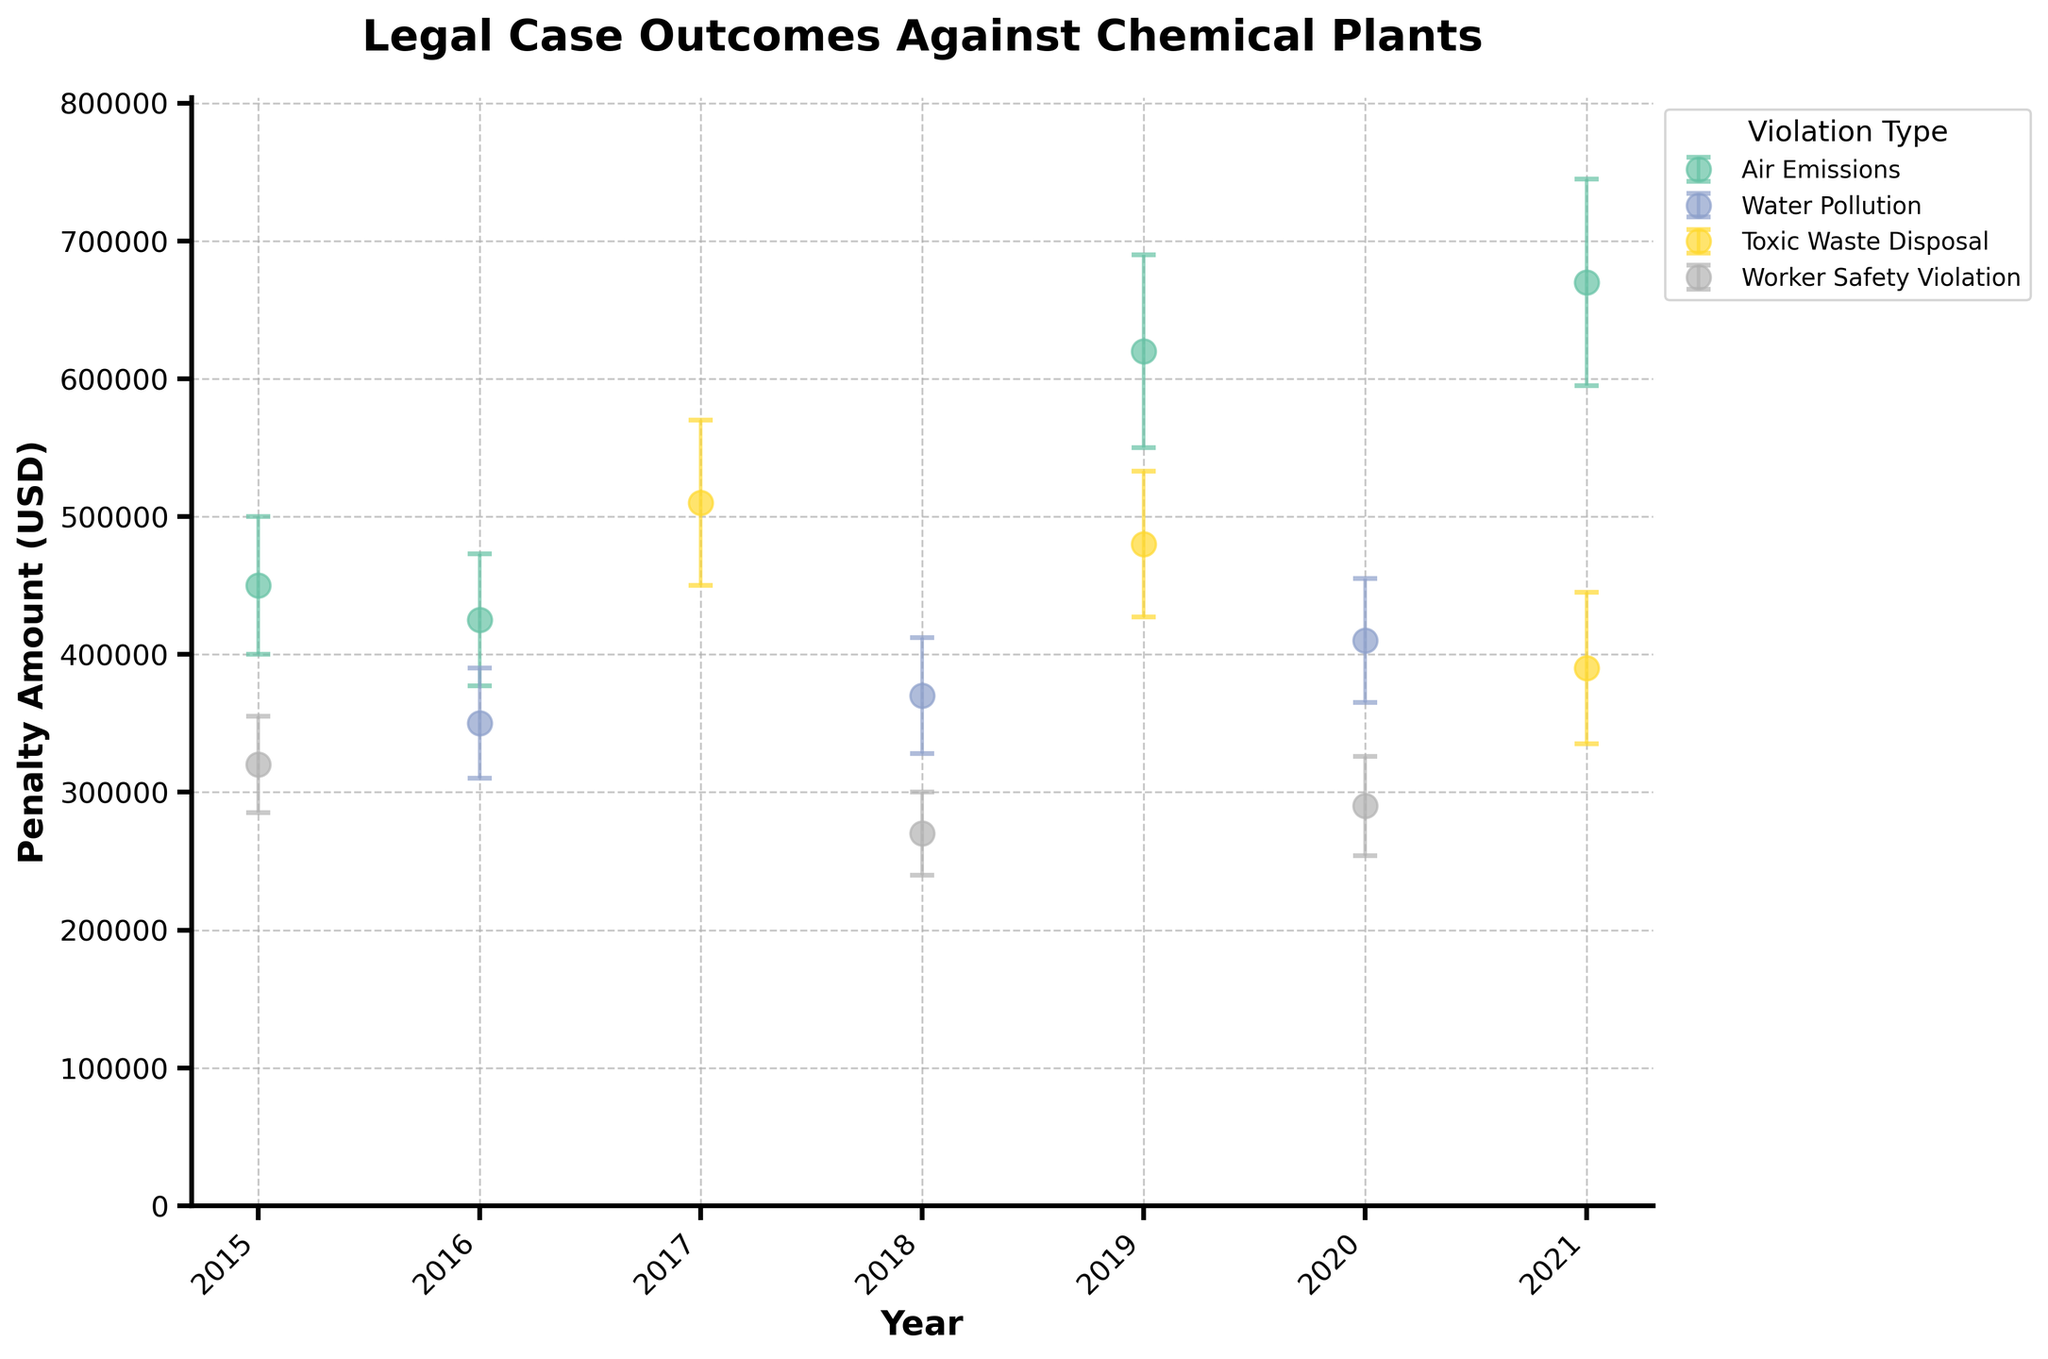What is the title of the figure? The title is usually displayed at the top of the figure. In this case, it reads "Legal Case Outcomes Against Chemical Plants."
Answer: Legal Case Outcomes Against Chemical Plants Which chemical plant has the highest penalty amount in 2021? By looking at the data points for 2021, we can see the highest penalty amount is for Dow Chemical. The dot representing Dow Chemical in 2021 is above the other points for that year.
Answer: Dow Chemical What is the penalty amount for ExxonMobil in 2019? Identify the data point for ExxonMobil in 2019. The y-axis label at that point shows the penalty amount.
Answer: 620,000 USD Which year has the highest number of violations? Count the number of points for each year. The year with the most points represents the highest number of violations.
Answer: 2021 What is the average penalty amount for water pollution violations? Locate all the points corresponding to water pollution violations, sum their penalty amounts, and then divide by the number of such violations. (350,000 + 410,000 + 370,000) / 3 = 376,667
Answer: 376,667 USD Which violation type has the most spread in penalty amounts? By comparing the vertical spread of error bars for each violation type, we note that toxic waste disposal violations have the largest spread.
Answer: Toxic Waste Disposal Which violation type has the highest penalty amount recorded on the plot? Compare the highest points across violation types. Toxic waste disposal has the highest point recorded for 2017.
Answer: Toxic Waste Disposal Was the penalty amount for air emissions always increasing over time? Track the points for air emissions from 2015 through 2021. Note that it's not consistent; for instance, there is a dip in 2016.
Answer: No What is the difference in penalty amount between the highest and the lowest penalty amount for worker safety violations? Find the highest and lowest points for worker safety violations, then subtract the lowest amount from the highest amount. 320,000 - 270,000 = 50,000
Answer: 50,000 USD Which company received a judgment for worker safety violation and what was the penalty amount? Locate the point for worker safety violations with "Judgment" in the Outcome. Chevron in 2020 shows a penalty amount of 290,000 USD.
Answer: Chevron, 290,000 USD 